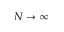Convert formula to latex. <formula><loc_0><loc_0><loc_500><loc_500>N \to \infty</formula> 